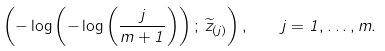<formula> <loc_0><loc_0><loc_500><loc_500>\left ( - \log \left ( - \log \left ( \frac { j } { m + 1 } \right ) \right ) ; \, \widetilde { z } _ { ( j ) } \right ) , \quad j = 1 , \dots , m .</formula> 